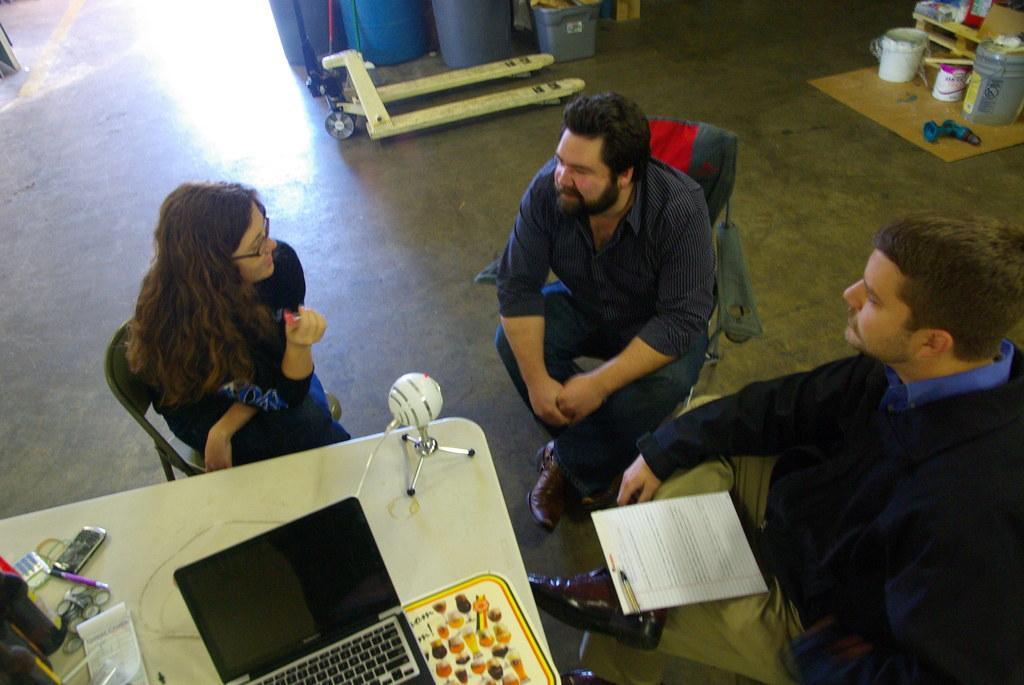Can you describe this image briefly? There are three people sitting on chairs and this man holding papers. We can see laptop,book,mobile and objects on the table. In the background we can see buckets,barrels and objects on the floor. 